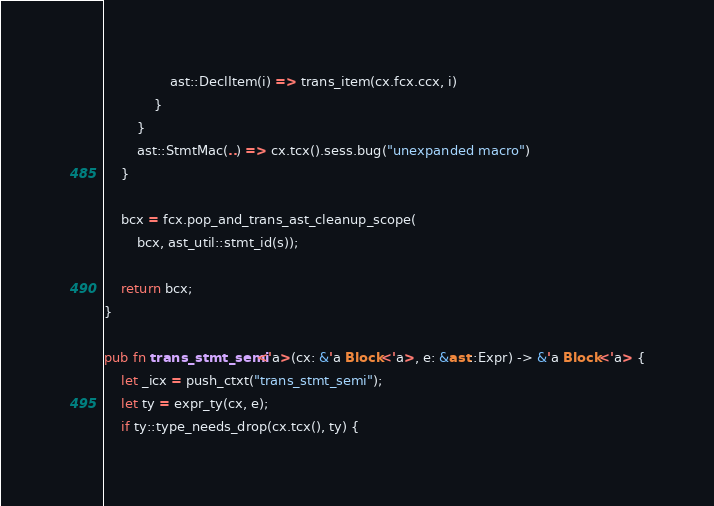Convert code to text. <code><loc_0><loc_0><loc_500><loc_500><_Rust_>                ast::DeclItem(i) => trans_item(cx.fcx.ccx, i)
            }
        }
        ast::StmtMac(..) => cx.tcx().sess.bug("unexpanded macro")
    }

    bcx = fcx.pop_and_trans_ast_cleanup_scope(
        bcx, ast_util::stmt_id(s));

    return bcx;
}

pub fn trans_stmt_semi<'a>(cx: &'a Block<'a>, e: &ast::Expr) -> &'a Block<'a> {
    let _icx = push_ctxt("trans_stmt_semi");
    let ty = expr_ty(cx, e);
    if ty::type_needs_drop(cx.tcx(), ty) {</code> 